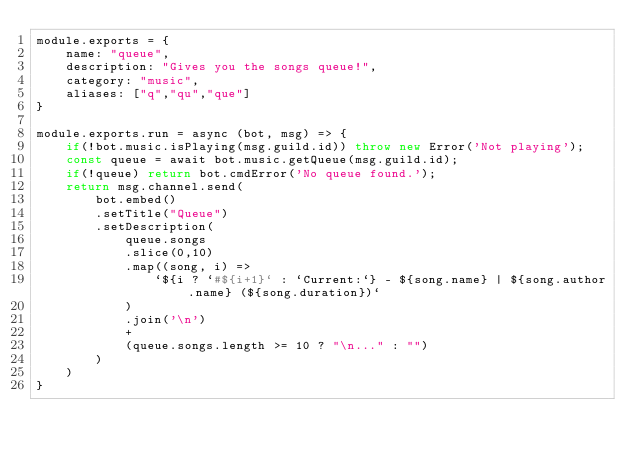<code> <loc_0><loc_0><loc_500><loc_500><_JavaScript_>module.exports = {
    name: "queue",
    description: "Gives you the songs queue!",
    category: "music",
    aliases: ["q","qu","que"]
}

module.exports.run = async (bot, msg) => {
    if(!bot.music.isPlaying(msg.guild.id)) throw new Error('Not playing');
    const queue = await bot.music.getQueue(msg.guild.id);
    if(!queue) return bot.cmdError('No queue found.');
    return msg.channel.send(
        bot.embed()
        .setTitle("Queue")
        .setDescription(
            queue.songs
            .slice(0,10)
            .map((song, i) =>
                `${i ? `#${i+1}` : `Current:`} - ${song.name} | ${song.author.name} (${song.duration})`
            )
            .join('\n')
            +
            (queue.songs.length >= 10 ? "\n..." : "")
        )
    )
}
</code> 